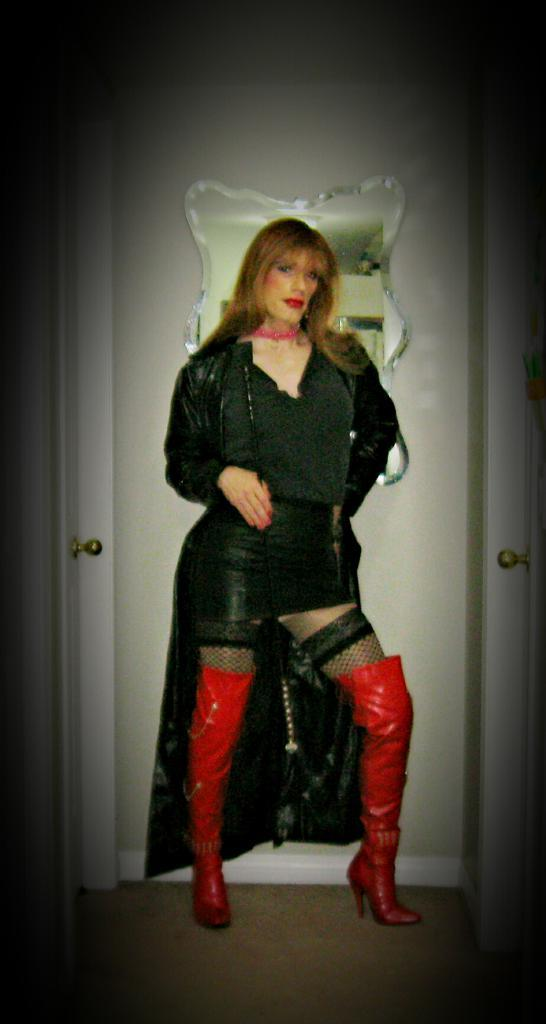What is the main subject of the image? There is a woman standing in the image. Where is the woman standing? The woman is standing on the ground. What can be seen in the background of the image? There is a door visible in the background of the image. What feature of the door is mentioned in the facts? There are door handles on the door. What type of crime is being committed in the image? There is no indication of a crime being committed in the image; it features a woman standing on the ground with a door visible in the background. How many plates are visible in the image? There are no plates present in the image. 